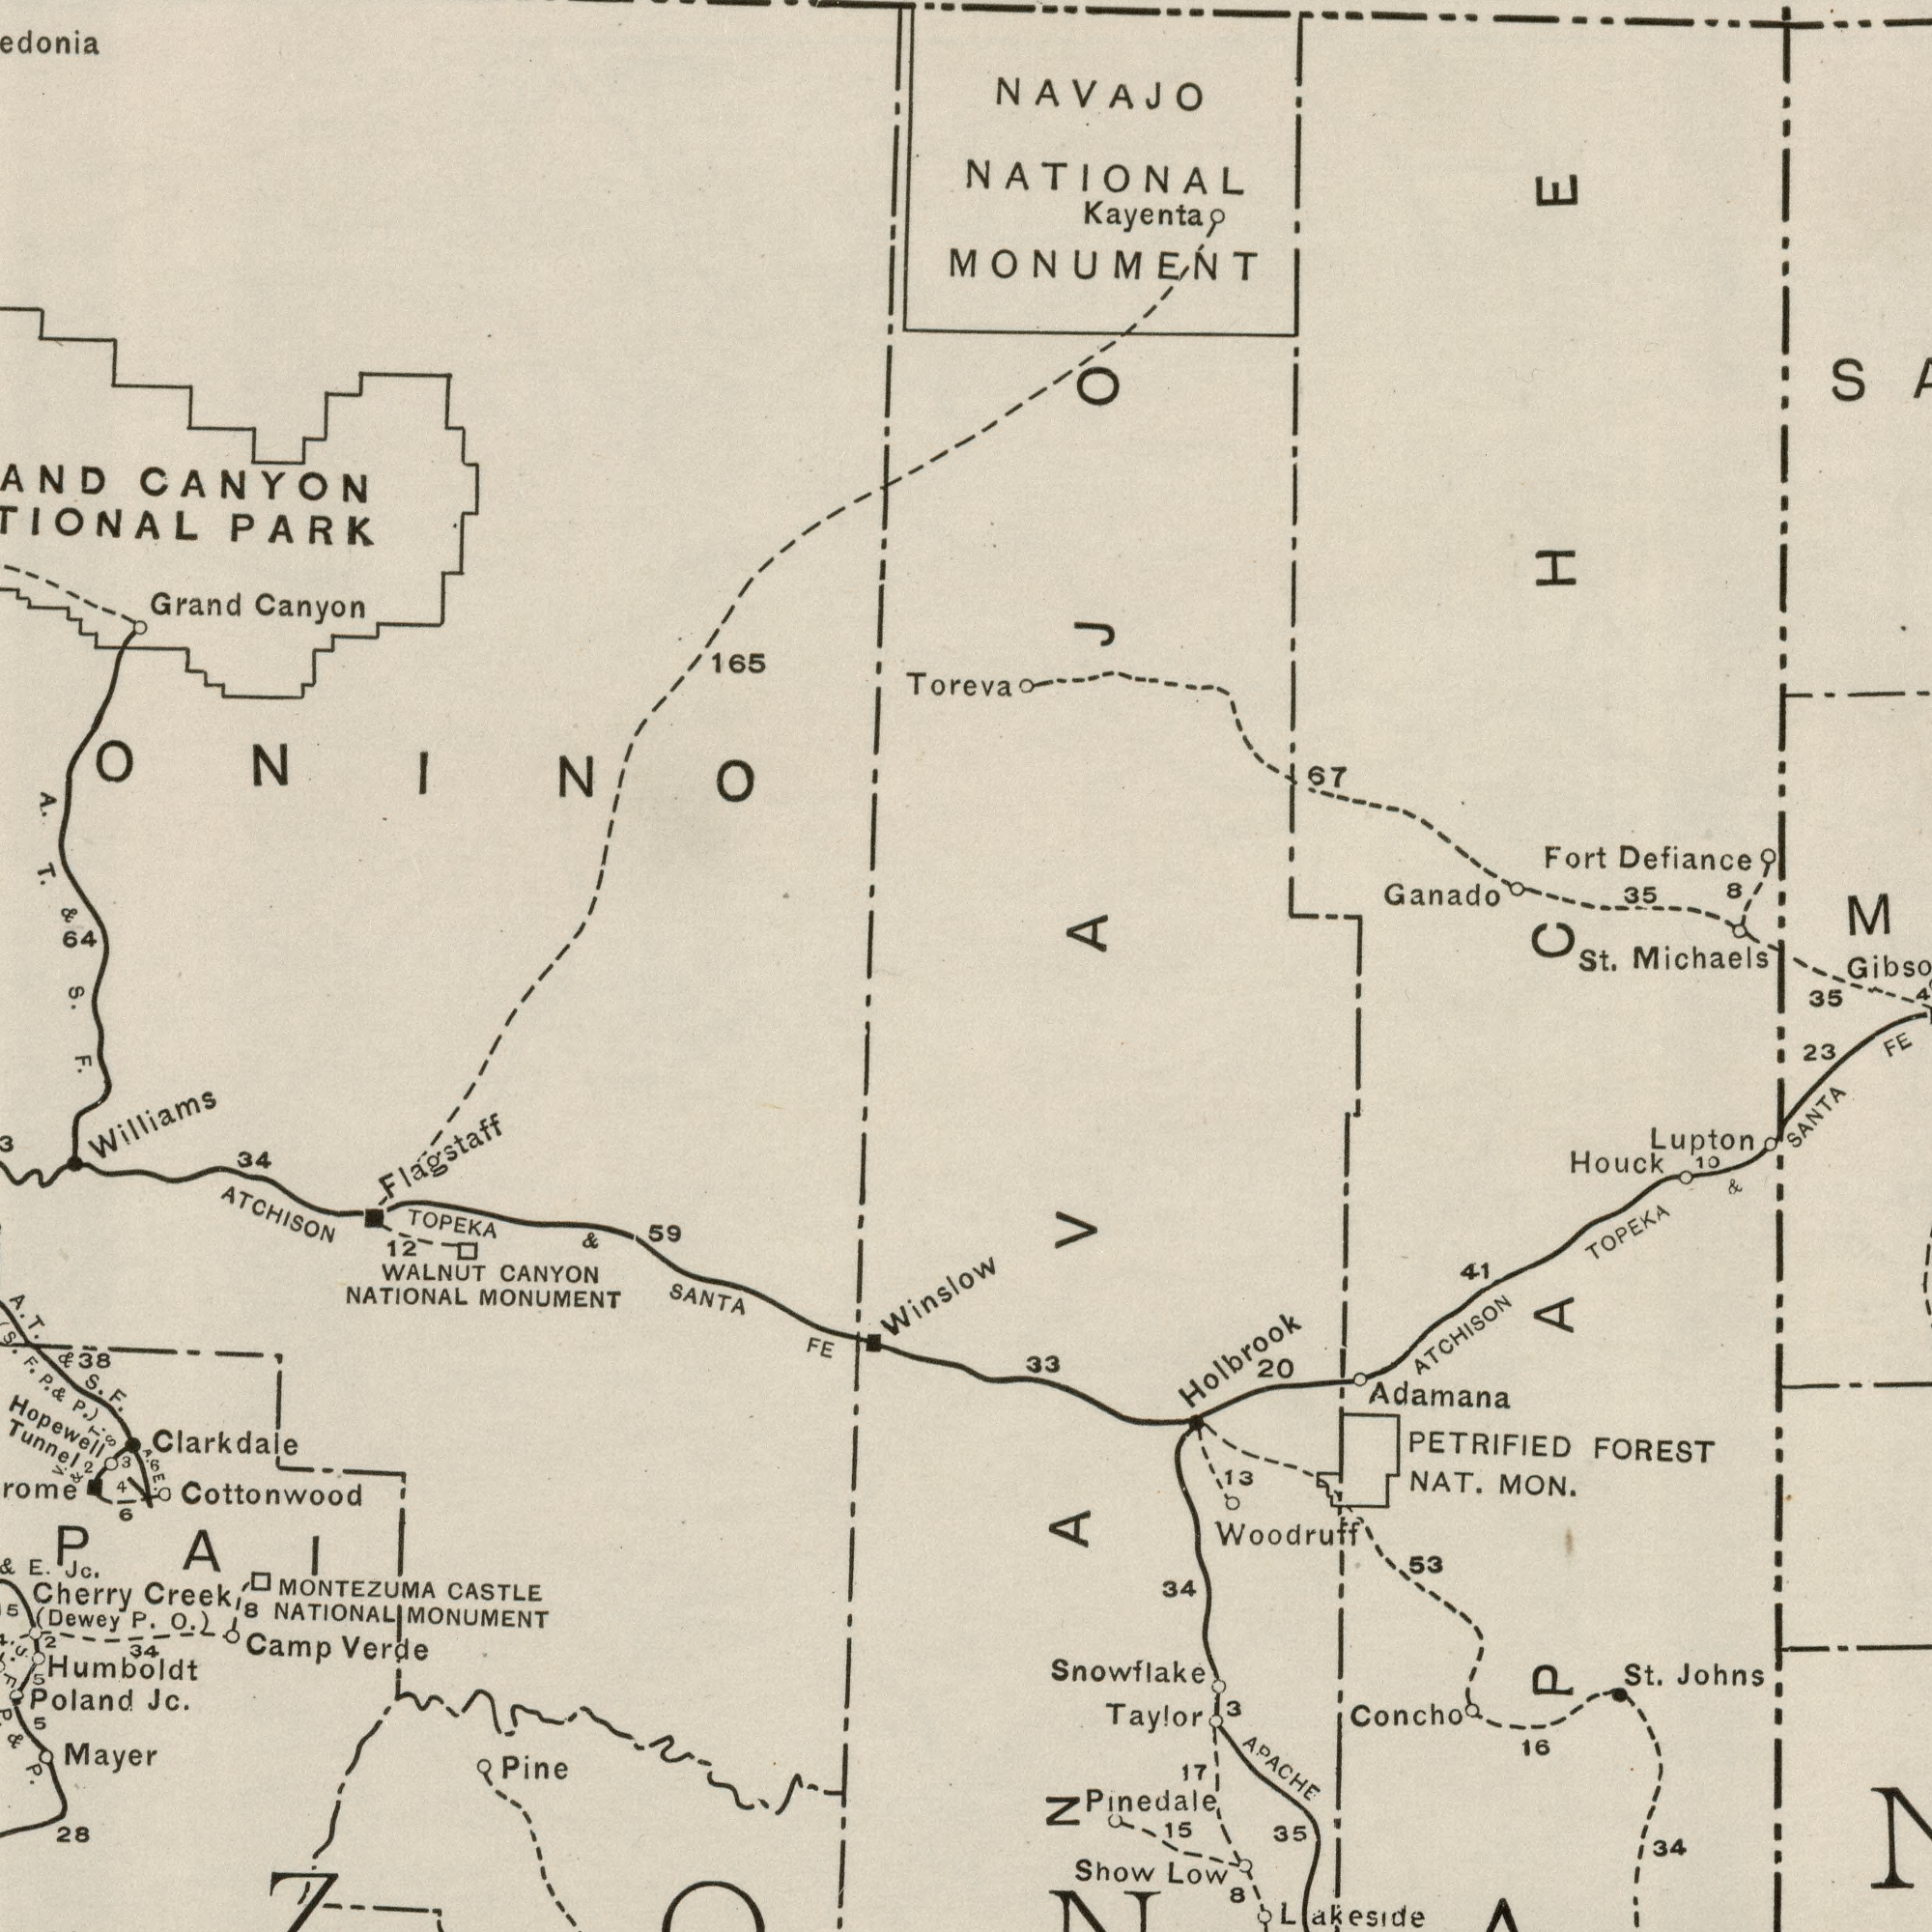What text is shown in the top-left quadrant? A. T. CANYON Canyon & 165 64 PARK Grand S. What text is shown in the top-right quadrant? Toreva Ganado Defiance NAVAJO Kayenta NATIONAL Michaels Fort MONUMENT 35 67 8 St. 35 What text can you see in the bottom-right section? Pinedale APACHE Snowflake MON. Adamana Show TOPEKA ATCHISON Concho Johns Houck FOREST Woodruff Low 23 53 SANTA 35 PETRIFIED NAT. FE Taylor St. 16 Lakeside 33 41 Lupton 17 13 34 20 3 8 10 34 & Holbrook 15 What text appears in the bottom-left area of the image? Cottonwood Humboldt MOUNMENT Flagstaff Clarkdale Mayer TOPEKA Poland F. SANTA WALNUT CANYON 28 Jc. Cherry Camp Verde Winslow Pine 34 P. Creek ATCHISON FE 12 Tunnel (Dewey Jc. NATIONAL CASTLE E. & 59 38 Williams & P. MONTEZUMA 5 MOUNMENT NATIONAL 2 5 & 34 5 Hopewell A. T. & S. F. S. F. P. O.) 3 4 6 V. T. & S A. E. 6 (S. F. P. & P.) 8 2 